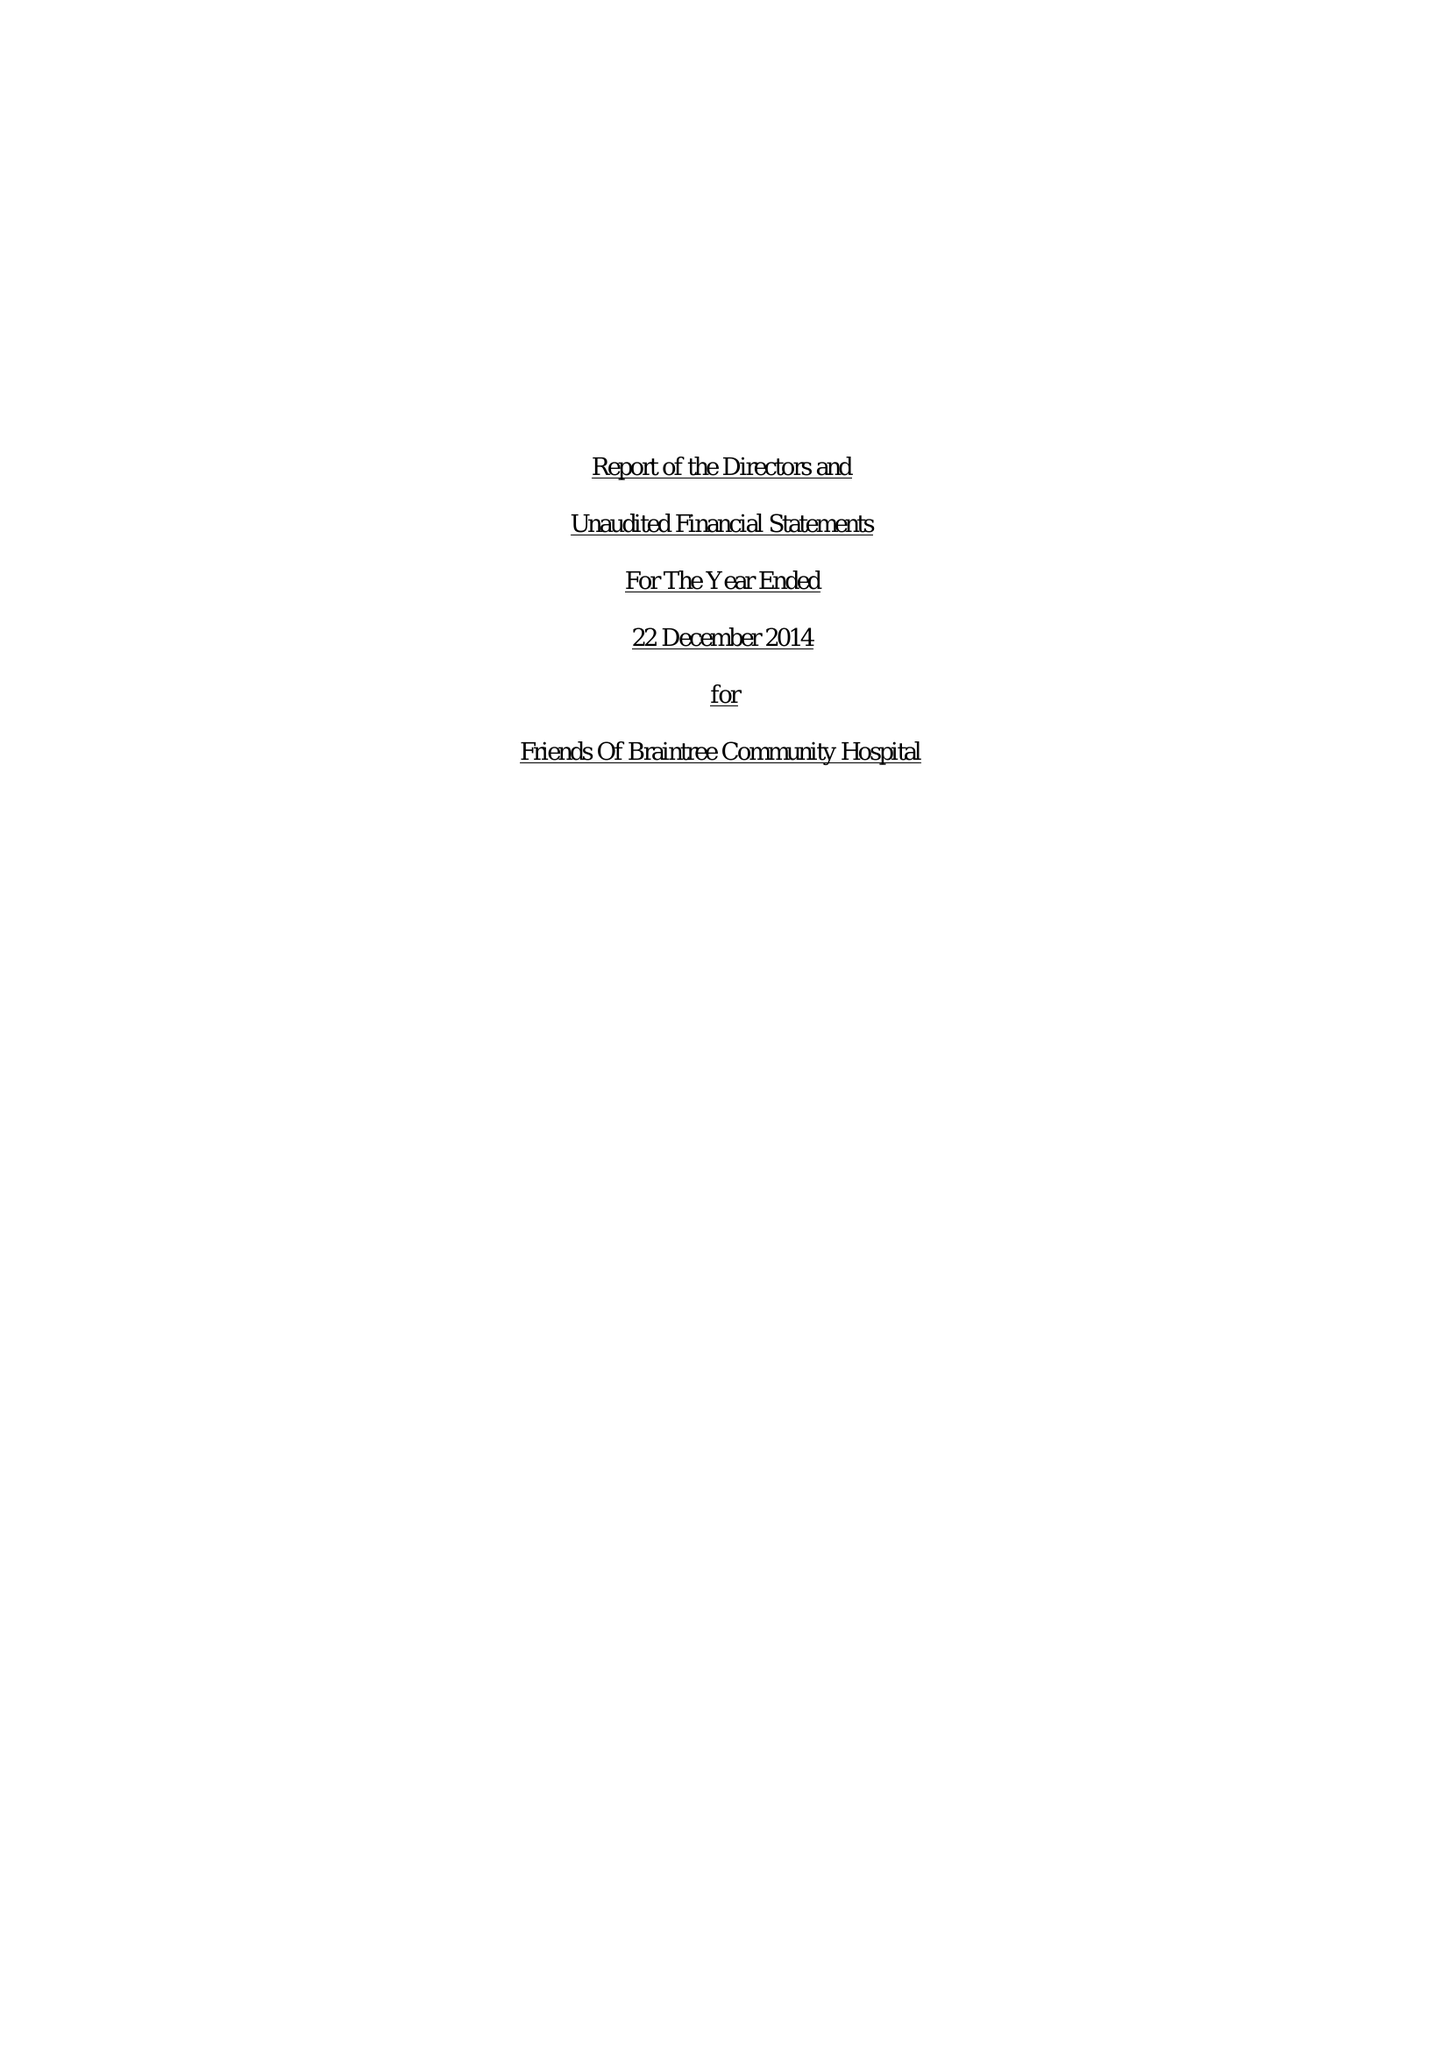What is the value for the address__street_line?
Answer the question using a single word or phrase. 82 HIGH GARRETT 